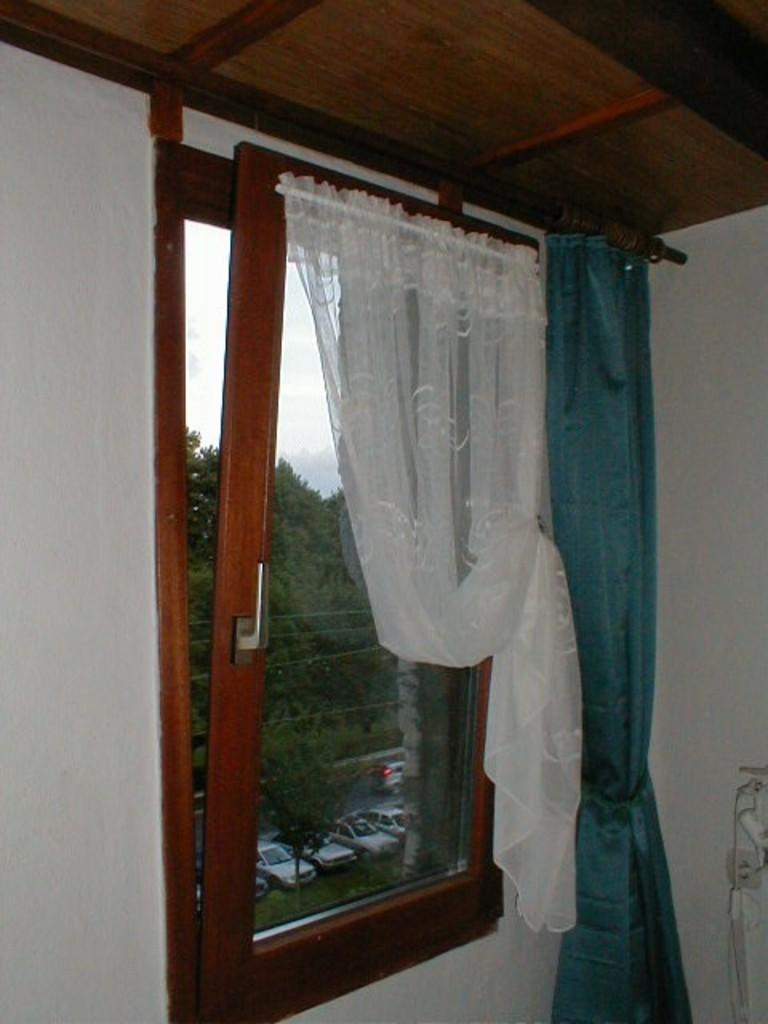What can be seen through the window in the image? Cars, trees, and the sky are visible through the window in the image. What is associated with the window in the image? There are curtains associated with the window in the image. What is visible on the wall in the image? The wall is visible in the image, but there is no specific detail mentioned about it. What is the condition of the sky in the image? The sky is visible through the window, and clouds are present in the sky. What type of lizard can be seen crawling on the minister's shoulder in the image? There is no minister or lizard present in the image. What type of airplane can be seen flying through the sky in the image? There is no airplane visible in the sky in the image. 